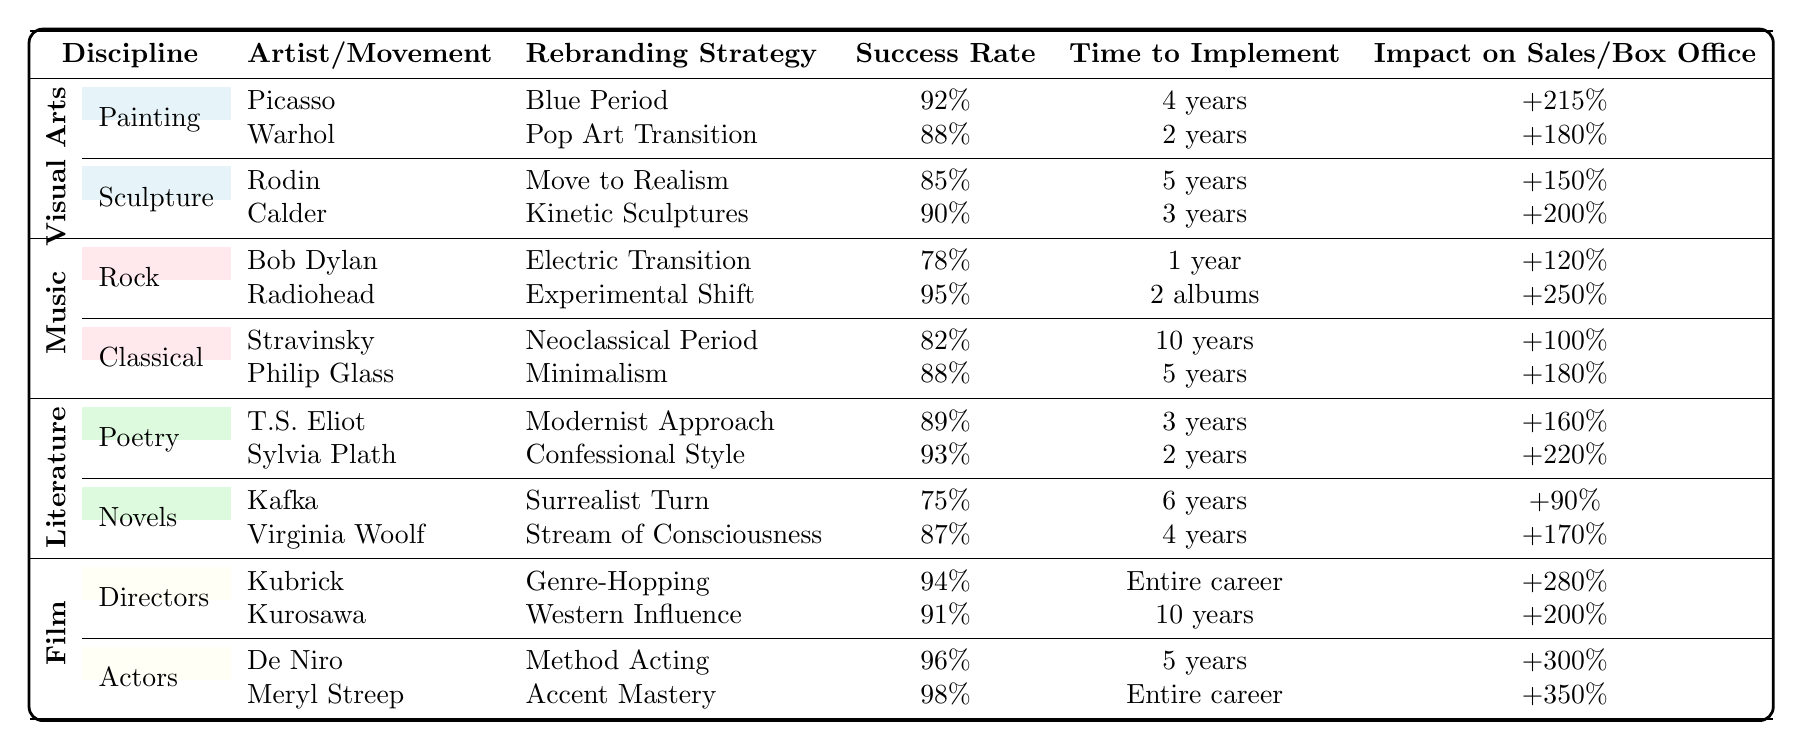What is the highest success rate among the rebranding strategies listed? The highest success rate is found in Meryl Streep's Accent Mastery with a success rate of 98%. This can be identified by comparing the success rates across all strategies in the table.
Answer: 98% Which rebranding strategy took the longest to implement? The rebranding strategy with the longest implementation time is Stravinsky's Neoclassical Period, which took 10 years. This is found by checking the time to implement for all strategies.
Answer: 10 years What was the impact on sales for Philip Glass's Minimalism? The impact on sales for Philip Glass's Minimalism was +180%, as stated directly in the row corresponding to that strategy in the table.
Answer: +180% How many years did it take to implement Picasso's Blue Period? According to the table, Picasso's Blue Period took 4 years to implement. This can be found by looking at the specific entry for that strategy in the table.
Answer: 4 years Is it true that all music rebranding strategies had a success rate above 80%? Yes, it is true. By examining the success rates listed for all the music strategies, they are 78%, 95%, 82%, and 88%, of which only Bob Dylan's Electric Transition is below 80%.
Answer: No What is the average impact on sales for visual arts strategies? To find the average, we sum the impact percentages (+215% + 180% + 150% + 200%) = 745%. There are 4 strategies, so average = 745% / 4 = 186.25%.
Answer: 186.25% What strategy had the best impact on box office revenue in film? The strategy with the best impact on box office revenue is De Niro's Method Acting, which had an impact of +300%. This is found by reviewing the box office impacts across the film strategies.
Answer: +300% Which artistic discipline had the overall highest success rates among its strategies? The discipline with the highest overall success rate is Film, as the lowest success rate within it (91% for Kurosawa) is higher than the lowest in any other discipline.
Answer: Film How do the average success rates of literature and music compare? The average success rate for literature is (89% + 93% + 75% + 87%)/4 = 86.25%. The average for music is (78% + 95% + 82% + 88%)/4 = 85.75%. Literature's average success rate is higher.
Answer: Literature is higher What percentage did Radiohead's Experimental Shift increase sales by? Radiohead's Experimental Shift resulted in a sales increase of +250%. This value is directly listed in the table under the music section.
Answer: +250% 